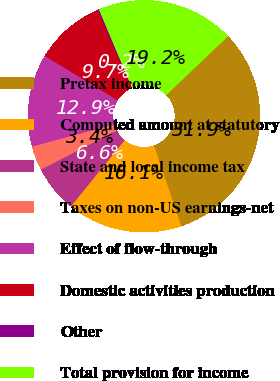Convert chart. <chart><loc_0><loc_0><loc_500><loc_500><pie_chart><fcel>Pretax income<fcel>Computed amount at statutory<fcel>State and local income tax<fcel>Taxes on non-US earnings-net<fcel>Effect of flow-through<fcel>Domestic activities production<fcel>Other<fcel>Total provision for income<nl><fcel>31.91%<fcel>16.06%<fcel>6.56%<fcel>3.39%<fcel>12.9%<fcel>9.73%<fcel>0.22%<fcel>19.23%<nl></chart> 